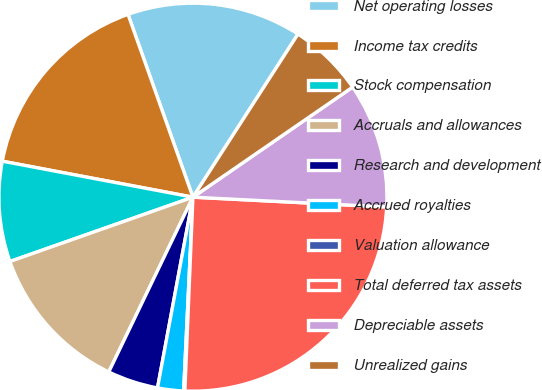Convert chart. <chart><loc_0><loc_0><loc_500><loc_500><pie_chart><fcel>Net operating losses<fcel>Income tax credits<fcel>Stock compensation<fcel>Accruals and allowances<fcel>Research and development<fcel>Accrued royalties<fcel>Valuation allowance<fcel>Total deferred tax assets<fcel>Depreciable assets<fcel>Unrealized gains<nl><fcel>14.54%<fcel>16.6%<fcel>8.35%<fcel>12.48%<fcel>4.22%<fcel>2.16%<fcel>0.1%<fcel>24.86%<fcel>10.41%<fcel>6.29%<nl></chart> 